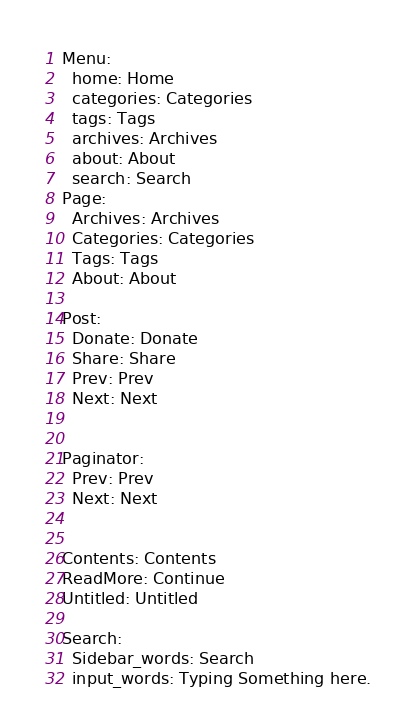Convert code to text. <code><loc_0><loc_0><loc_500><loc_500><_YAML_>Menu:
  home: Home
  categories: Categories
  tags: Tags
  archives: Archives
  about: About
  search: Search
Page:
  Archives: Archives
  Categories: Categories
  Tags: Tags
  About: About

Post:
  Donate: Donate
  Share: Share
  Prev: Prev
  Next: Next
  
  
Paginator: 
  Prev: Prev
  Next: Next


Contents: Contents
ReadMore: Continue
Untitled: Untitled

Search:
  Sidebar_words: Search
  input_words: Typing Something here.</code> 